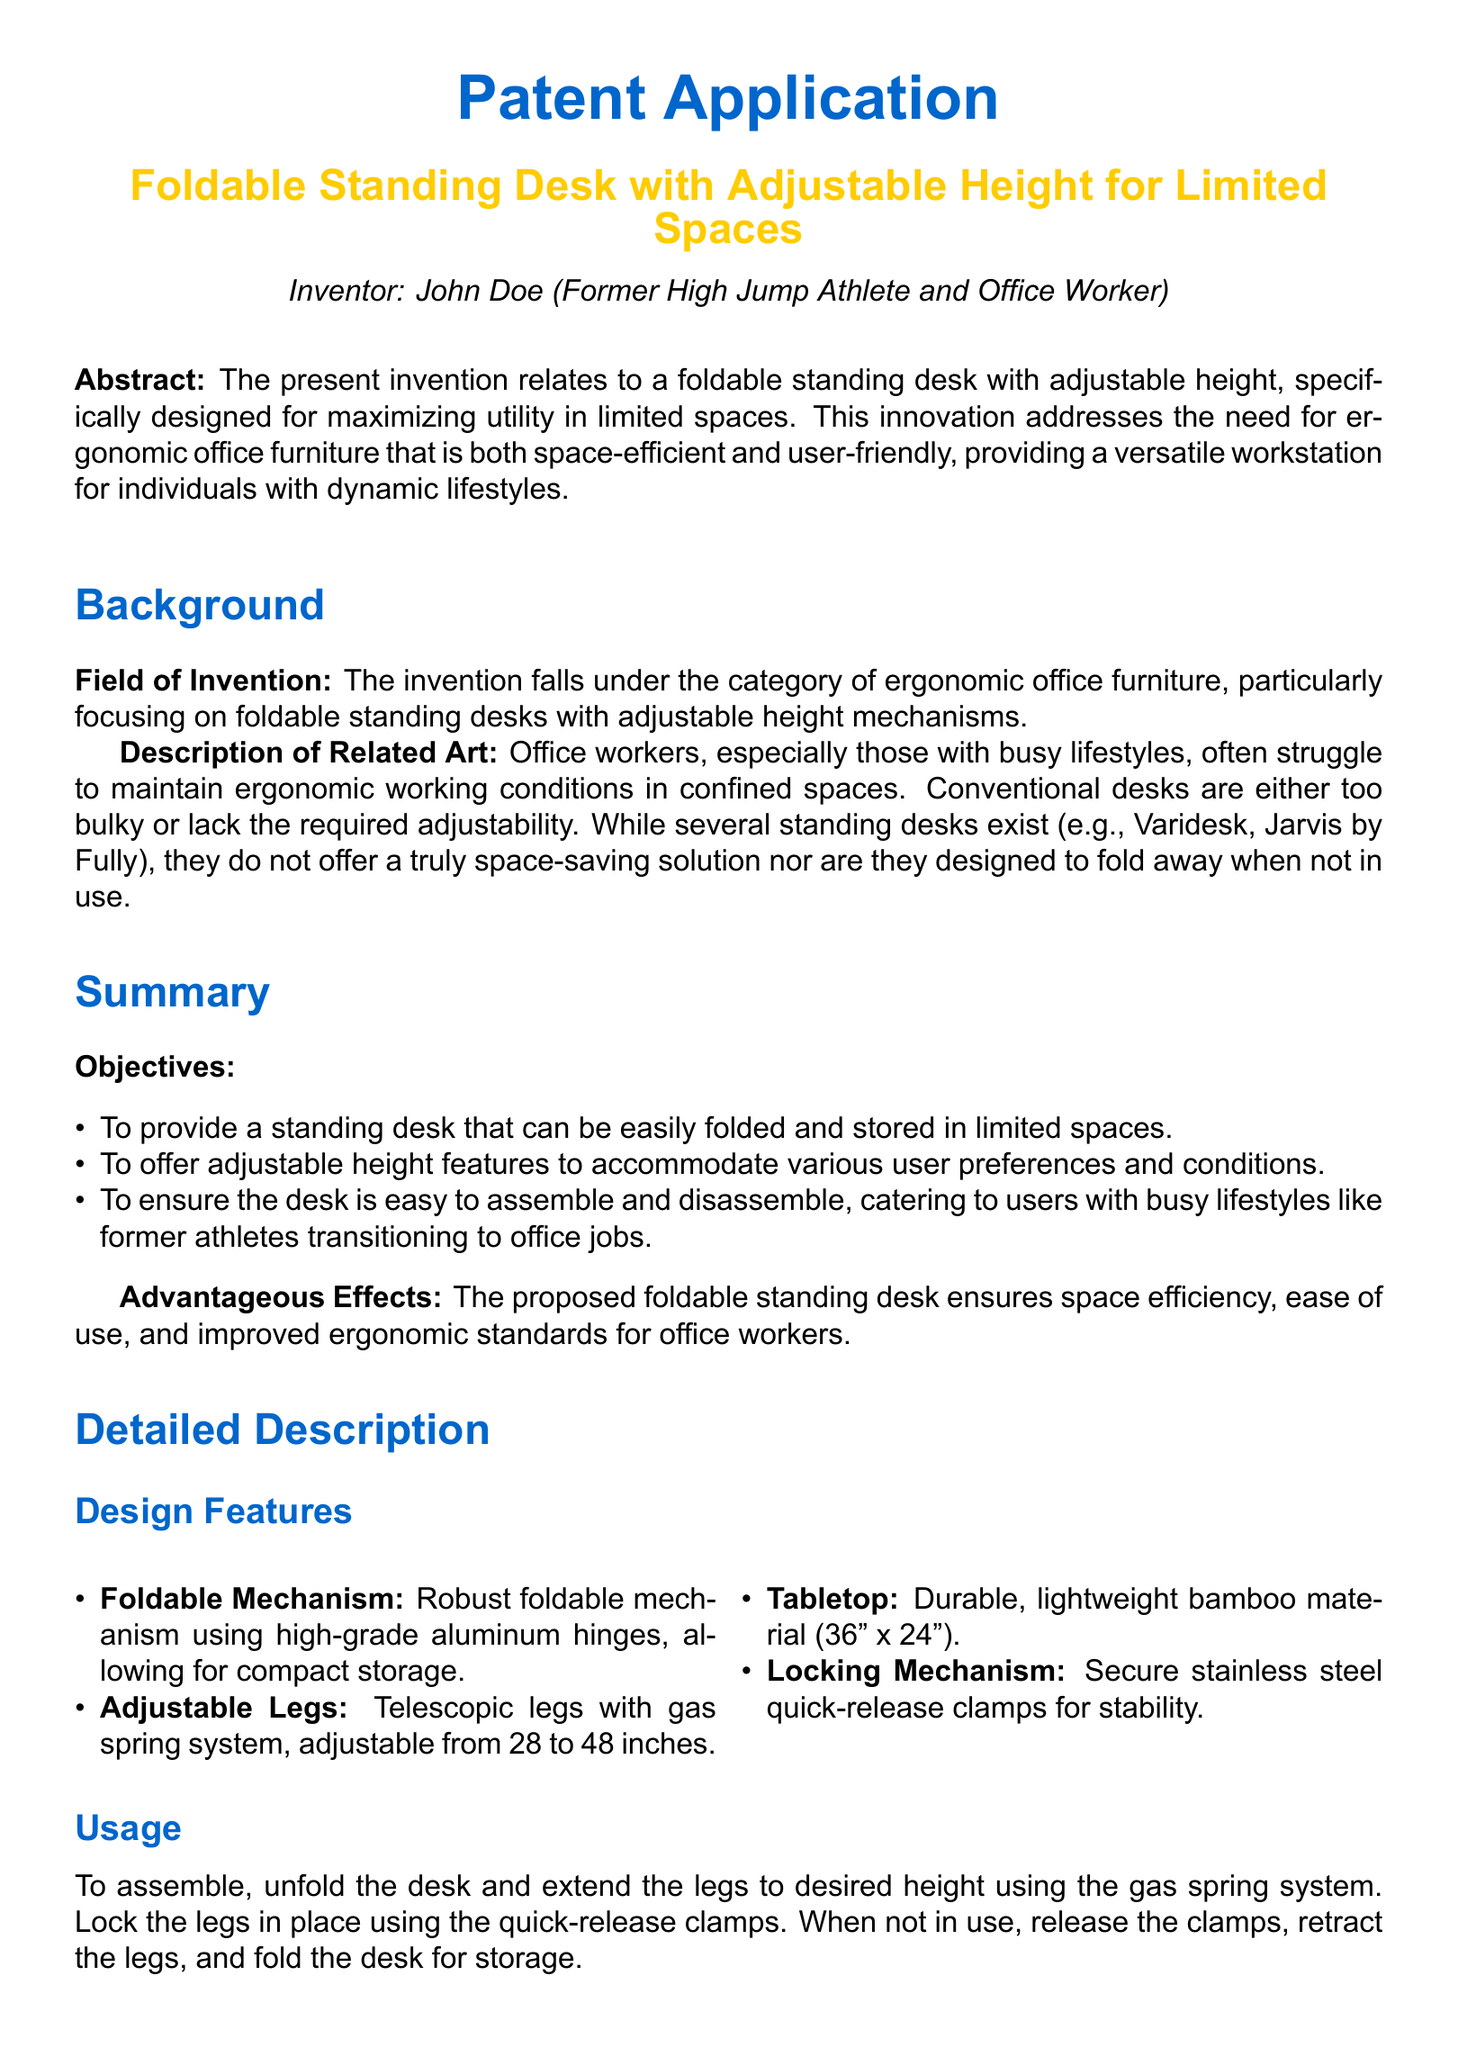what is the title of the patent application? The title of the patent application is presented prominently in the document.
Answer: Foldable Standing Desk with Adjustable Height for Limited Spaces who is the inventor of the desk? The inventor's name is mentioned in the introduction section of the document.
Answer: John Doe what material is the tabletop made of? The material used for the tabletop is specified in the design features section.
Answer: bamboo what is the height adjustment range of the desk? The range of height adjustment is detailed in the claims section of the document.
Answer: 28 to 48 inches how many objectives are stated in the summary? The number of objectives is listed as bullet points in the summary section.
Answer: three what mechanism is used for height adjustment? The mechanism for height adjustment is described in the design features.
Answer: gas spring system what is a key advantage of using this desk? The advantageous effects of the proposed desk are summarized in the document.
Answer: space efficiency what type of furniture does this patent relate to? The field of invention is stated at the beginning of the document.
Answer: ergonomic office furniture how is the desk stored when not in use? The usage section describes the procedure for storing the desk.
Answer: fold the desk 